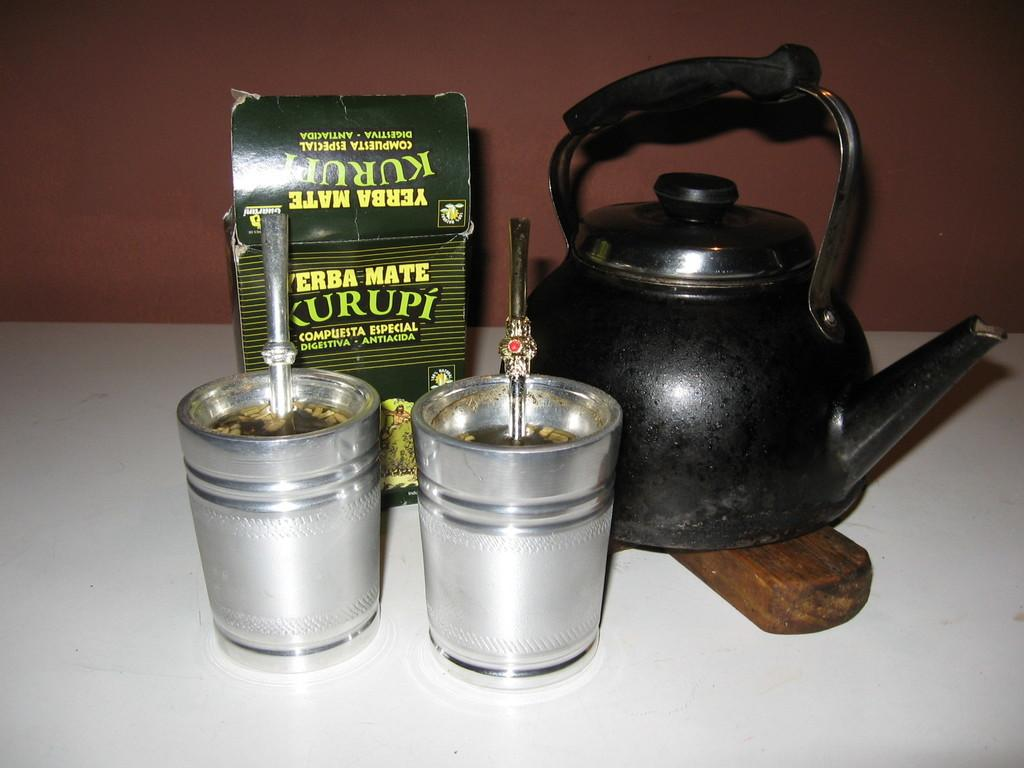What is the main object in the image? There is a teapot in the image. What objects are near the teapot? There are two glasses beside the teapot. What else can be seen in the image? There is an opened box in the image. What is visible behind the teapot? There is a wall behind the teapot. Reasoning: Let's think step by step by step in order to produce the conversation. We start by identifying the main object in the image, which is the teapot. Then, we describe the objects near the teapot, which are the two glasses. Next, we mention the opened box as another item visible in the image. Finally, we describe the background by mentioning the wall behind the teapot. Each question is designed to elicit a specific detail about the image that is known from the provided facts. What type of popcorn is being served in the teapot? There is no popcorn present in the image; it is a teapot with two glasses and an opened box. What activity is taking place with the eggnog in the image? There is no eggnog present in the image; it is a teapot with two glasses and an opened box. 